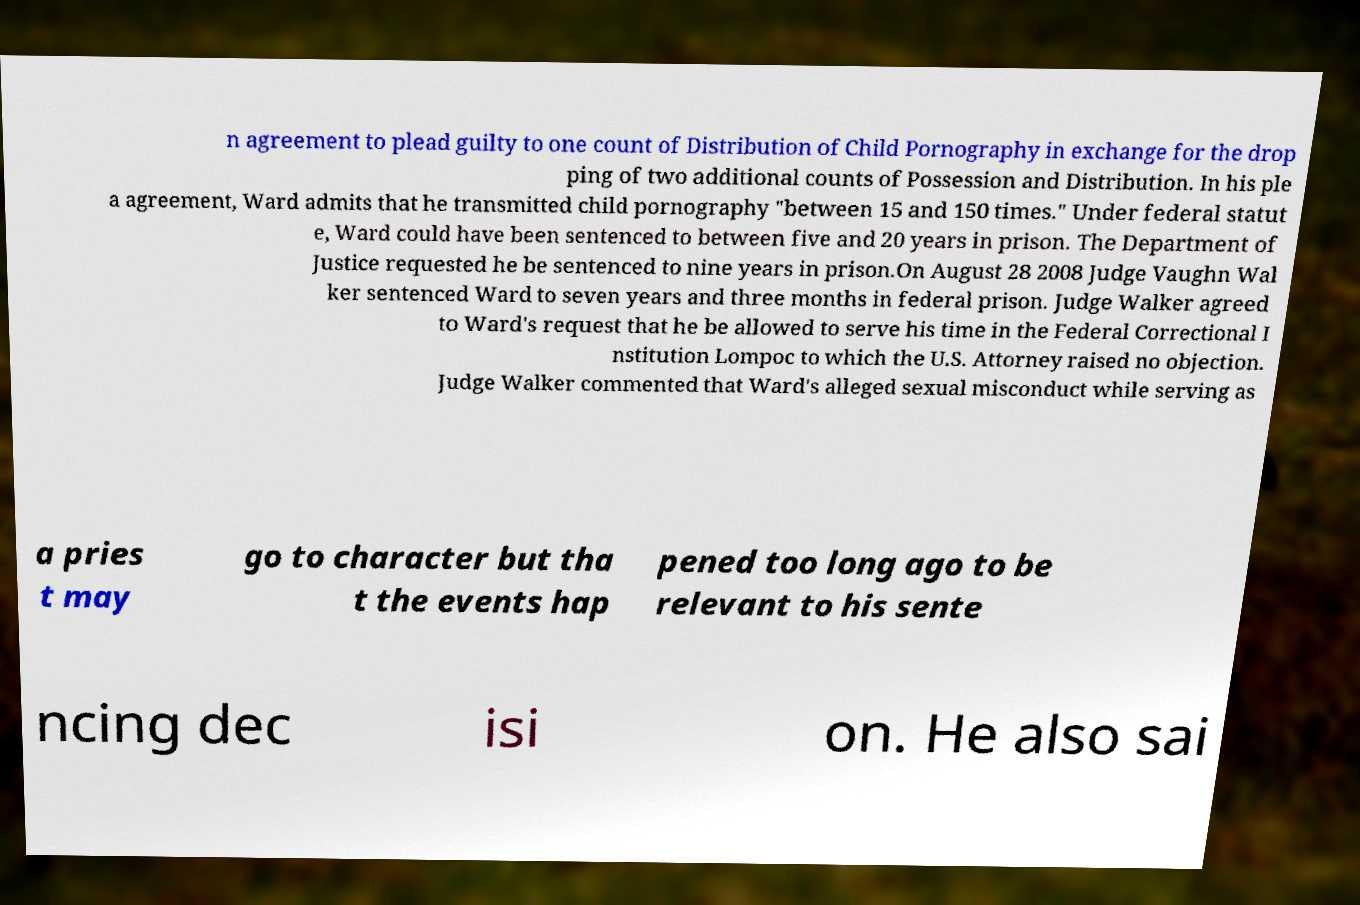There's text embedded in this image that I need extracted. Can you transcribe it verbatim? n agreement to plead guilty to one count of Distribution of Child Pornography in exchange for the drop ping of two additional counts of Possession and Distribution. In his ple a agreement, Ward admits that he transmitted child pornography "between 15 and 150 times." Under federal statut e, Ward could have been sentenced to between five and 20 years in prison. The Department of Justice requested he be sentenced to nine years in prison.On August 28 2008 Judge Vaughn Wal ker sentenced Ward to seven years and three months in federal prison. Judge Walker agreed to Ward's request that he be allowed to serve his time in the Federal Correctional I nstitution Lompoc to which the U.S. Attorney raised no objection. Judge Walker commented that Ward's alleged sexual misconduct while serving as a pries t may go to character but tha t the events hap pened too long ago to be relevant to his sente ncing dec isi on. He also sai 